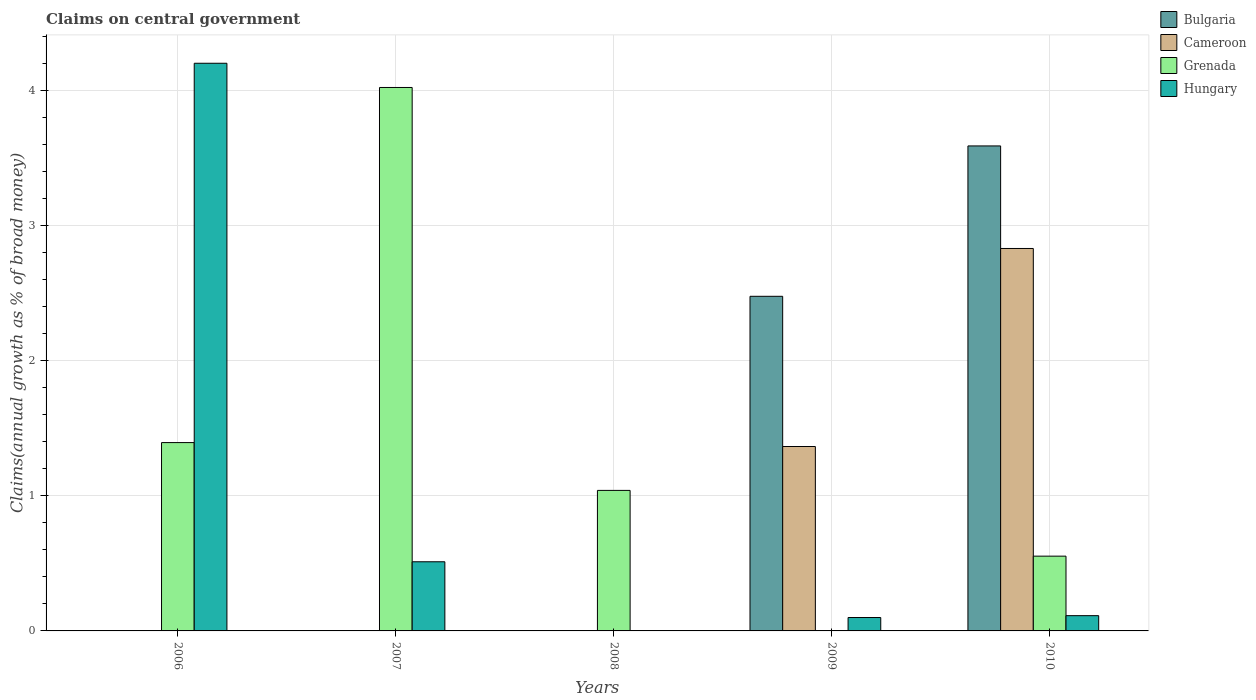Are the number of bars per tick equal to the number of legend labels?
Make the answer very short. No. What is the percentage of broad money claimed on centeral government in Hungary in 2007?
Make the answer very short. 0.51. Across all years, what is the maximum percentage of broad money claimed on centeral government in Bulgaria?
Offer a very short reply. 3.59. What is the total percentage of broad money claimed on centeral government in Bulgaria in the graph?
Give a very brief answer. 6.07. What is the difference between the percentage of broad money claimed on centeral government in Grenada in 2006 and that in 2010?
Your response must be concise. 0.84. What is the difference between the percentage of broad money claimed on centeral government in Cameroon in 2008 and the percentage of broad money claimed on centeral government in Bulgaria in 2009?
Give a very brief answer. -2.48. What is the average percentage of broad money claimed on centeral government in Bulgaria per year?
Keep it short and to the point. 1.21. In the year 2007, what is the difference between the percentage of broad money claimed on centeral government in Hungary and percentage of broad money claimed on centeral government in Grenada?
Ensure brevity in your answer.  -3.51. What is the ratio of the percentage of broad money claimed on centeral government in Grenada in 2006 to that in 2007?
Give a very brief answer. 0.35. What is the difference between the highest and the second highest percentage of broad money claimed on centeral government in Grenada?
Give a very brief answer. 2.63. What is the difference between the highest and the lowest percentage of broad money claimed on centeral government in Grenada?
Your answer should be compact. 4.03. What is the difference between two consecutive major ticks on the Y-axis?
Make the answer very short. 1. Does the graph contain any zero values?
Your response must be concise. Yes. How are the legend labels stacked?
Give a very brief answer. Vertical. What is the title of the graph?
Provide a short and direct response. Claims on central government. What is the label or title of the X-axis?
Keep it short and to the point. Years. What is the label or title of the Y-axis?
Provide a short and direct response. Claims(annual growth as % of broad money). What is the Claims(annual growth as % of broad money) in Bulgaria in 2006?
Your answer should be very brief. 0. What is the Claims(annual growth as % of broad money) of Cameroon in 2006?
Provide a short and direct response. 0. What is the Claims(annual growth as % of broad money) in Grenada in 2006?
Keep it short and to the point. 1.4. What is the Claims(annual growth as % of broad money) in Hungary in 2006?
Make the answer very short. 4.21. What is the Claims(annual growth as % of broad money) of Bulgaria in 2007?
Your answer should be compact. 0. What is the Claims(annual growth as % of broad money) of Grenada in 2007?
Your response must be concise. 4.03. What is the Claims(annual growth as % of broad money) in Hungary in 2007?
Ensure brevity in your answer.  0.51. What is the Claims(annual growth as % of broad money) of Bulgaria in 2008?
Offer a terse response. 0. What is the Claims(annual growth as % of broad money) in Cameroon in 2008?
Make the answer very short. 0. What is the Claims(annual growth as % of broad money) of Grenada in 2008?
Give a very brief answer. 1.04. What is the Claims(annual growth as % of broad money) in Bulgaria in 2009?
Keep it short and to the point. 2.48. What is the Claims(annual growth as % of broad money) of Cameroon in 2009?
Provide a succinct answer. 1.37. What is the Claims(annual growth as % of broad money) in Grenada in 2009?
Give a very brief answer. 0. What is the Claims(annual growth as % of broad money) of Hungary in 2009?
Give a very brief answer. 0.1. What is the Claims(annual growth as % of broad money) of Bulgaria in 2010?
Provide a short and direct response. 3.59. What is the Claims(annual growth as % of broad money) in Cameroon in 2010?
Offer a terse response. 2.83. What is the Claims(annual growth as % of broad money) in Grenada in 2010?
Your answer should be compact. 0.55. What is the Claims(annual growth as % of broad money) in Hungary in 2010?
Provide a short and direct response. 0.11. Across all years, what is the maximum Claims(annual growth as % of broad money) in Bulgaria?
Your answer should be very brief. 3.59. Across all years, what is the maximum Claims(annual growth as % of broad money) of Cameroon?
Give a very brief answer. 2.83. Across all years, what is the maximum Claims(annual growth as % of broad money) in Grenada?
Your response must be concise. 4.03. Across all years, what is the maximum Claims(annual growth as % of broad money) in Hungary?
Your answer should be very brief. 4.21. Across all years, what is the minimum Claims(annual growth as % of broad money) in Bulgaria?
Offer a terse response. 0. Across all years, what is the minimum Claims(annual growth as % of broad money) in Cameroon?
Give a very brief answer. 0. What is the total Claims(annual growth as % of broad money) in Bulgaria in the graph?
Provide a succinct answer. 6.07. What is the total Claims(annual growth as % of broad money) of Cameroon in the graph?
Offer a very short reply. 4.2. What is the total Claims(annual growth as % of broad money) of Grenada in the graph?
Ensure brevity in your answer.  7.02. What is the total Claims(annual growth as % of broad money) of Hungary in the graph?
Keep it short and to the point. 4.93. What is the difference between the Claims(annual growth as % of broad money) of Grenada in 2006 and that in 2007?
Your answer should be compact. -2.63. What is the difference between the Claims(annual growth as % of broad money) in Hungary in 2006 and that in 2007?
Your answer should be compact. 3.69. What is the difference between the Claims(annual growth as % of broad money) in Grenada in 2006 and that in 2008?
Offer a very short reply. 0.35. What is the difference between the Claims(annual growth as % of broad money) in Hungary in 2006 and that in 2009?
Your answer should be compact. 4.11. What is the difference between the Claims(annual growth as % of broad money) of Grenada in 2006 and that in 2010?
Offer a terse response. 0.84. What is the difference between the Claims(annual growth as % of broad money) of Hungary in 2006 and that in 2010?
Provide a short and direct response. 4.09. What is the difference between the Claims(annual growth as % of broad money) of Grenada in 2007 and that in 2008?
Your response must be concise. 2.98. What is the difference between the Claims(annual growth as % of broad money) of Hungary in 2007 and that in 2009?
Offer a very short reply. 0.41. What is the difference between the Claims(annual growth as % of broad money) of Grenada in 2007 and that in 2010?
Provide a succinct answer. 3.47. What is the difference between the Claims(annual growth as % of broad money) of Hungary in 2007 and that in 2010?
Give a very brief answer. 0.4. What is the difference between the Claims(annual growth as % of broad money) in Grenada in 2008 and that in 2010?
Your answer should be compact. 0.49. What is the difference between the Claims(annual growth as % of broad money) in Bulgaria in 2009 and that in 2010?
Give a very brief answer. -1.11. What is the difference between the Claims(annual growth as % of broad money) of Cameroon in 2009 and that in 2010?
Your response must be concise. -1.47. What is the difference between the Claims(annual growth as % of broad money) of Hungary in 2009 and that in 2010?
Your response must be concise. -0.01. What is the difference between the Claims(annual growth as % of broad money) of Grenada in 2006 and the Claims(annual growth as % of broad money) of Hungary in 2007?
Your answer should be compact. 0.88. What is the difference between the Claims(annual growth as % of broad money) of Grenada in 2006 and the Claims(annual growth as % of broad money) of Hungary in 2009?
Keep it short and to the point. 1.3. What is the difference between the Claims(annual growth as % of broad money) of Grenada in 2006 and the Claims(annual growth as % of broad money) of Hungary in 2010?
Your answer should be very brief. 1.28. What is the difference between the Claims(annual growth as % of broad money) of Grenada in 2007 and the Claims(annual growth as % of broad money) of Hungary in 2009?
Make the answer very short. 3.93. What is the difference between the Claims(annual growth as % of broad money) in Grenada in 2007 and the Claims(annual growth as % of broad money) in Hungary in 2010?
Ensure brevity in your answer.  3.91. What is the difference between the Claims(annual growth as % of broad money) of Grenada in 2008 and the Claims(annual growth as % of broad money) of Hungary in 2009?
Offer a terse response. 0.94. What is the difference between the Claims(annual growth as % of broad money) in Grenada in 2008 and the Claims(annual growth as % of broad money) in Hungary in 2010?
Provide a succinct answer. 0.93. What is the difference between the Claims(annual growth as % of broad money) of Bulgaria in 2009 and the Claims(annual growth as % of broad money) of Cameroon in 2010?
Your response must be concise. -0.35. What is the difference between the Claims(annual growth as % of broad money) in Bulgaria in 2009 and the Claims(annual growth as % of broad money) in Grenada in 2010?
Make the answer very short. 1.92. What is the difference between the Claims(annual growth as % of broad money) of Bulgaria in 2009 and the Claims(annual growth as % of broad money) of Hungary in 2010?
Make the answer very short. 2.37. What is the difference between the Claims(annual growth as % of broad money) of Cameroon in 2009 and the Claims(annual growth as % of broad money) of Grenada in 2010?
Keep it short and to the point. 0.81. What is the difference between the Claims(annual growth as % of broad money) of Cameroon in 2009 and the Claims(annual growth as % of broad money) of Hungary in 2010?
Ensure brevity in your answer.  1.25. What is the average Claims(annual growth as % of broad money) in Bulgaria per year?
Your answer should be very brief. 1.21. What is the average Claims(annual growth as % of broad money) in Cameroon per year?
Keep it short and to the point. 0.84. What is the average Claims(annual growth as % of broad money) in Grenada per year?
Make the answer very short. 1.4. In the year 2006, what is the difference between the Claims(annual growth as % of broad money) in Grenada and Claims(annual growth as % of broad money) in Hungary?
Your answer should be very brief. -2.81. In the year 2007, what is the difference between the Claims(annual growth as % of broad money) of Grenada and Claims(annual growth as % of broad money) of Hungary?
Offer a terse response. 3.51. In the year 2009, what is the difference between the Claims(annual growth as % of broad money) in Bulgaria and Claims(annual growth as % of broad money) in Cameroon?
Your answer should be very brief. 1.11. In the year 2009, what is the difference between the Claims(annual growth as % of broad money) in Bulgaria and Claims(annual growth as % of broad money) in Hungary?
Your response must be concise. 2.38. In the year 2009, what is the difference between the Claims(annual growth as % of broad money) of Cameroon and Claims(annual growth as % of broad money) of Hungary?
Your answer should be very brief. 1.27. In the year 2010, what is the difference between the Claims(annual growth as % of broad money) in Bulgaria and Claims(annual growth as % of broad money) in Cameroon?
Your response must be concise. 0.76. In the year 2010, what is the difference between the Claims(annual growth as % of broad money) in Bulgaria and Claims(annual growth as % of broad money) in Grenada?
Your response must be concise. 3.04. In the year 2010, what is the difference between the Claims(annual growth as % of broad money) of Bulgaria and Claims(annual growth as % of broad money) of Hungary?
Your response must be concise. 3.48. In the year 2010, what is the difference between the Claims(annual growth as % of broad money) in Cameroon and Claims(annual growth as % of broad money) in Grenada?
Make the answer very short. 2.28. In the year 2010, what is the difference between the Claims(annual growth as % of broad money) of Cameroon and Claims(annual growth as % of broad money) of Hungary?
Make the answer very short. 2.72. In the year 2010, what is the difference between the Claims(annual growth as % of broad money) of Grenada and Claims(annual growth as % of broad money) of Hungary?
Your answer should be very brief. 0.44. What is the ratio of the Claims(annual growth as % of broad money) in Grenada in 2006 to that in 2007?
Your answer should be compact. 0.35. What is the ratio of the Claims(annual growth as % of broad money) in Hungary in 2006 to that in 2007?
Offer a terse response. 8.21. What is the ratio of the Claims(annual growth as % of broad money) in Grenada in 2006 to that in 2008?
Your response must be concise. 1.34. What is the ratio of the Claims(annual growth as % of broad money) of Hungary in 2006 to that in 2009?
Provide a short and direct response. 42.38. What is the ratio of the Claims(annual growth as % of broad money) in Grenada in 2006 to that in 2010?
Your response must be concise. 2.52. What is the ratio of the Claims(annual growth as % of broad money) of Hungary in 2006 to that in 2010?
Provide a succinct answer. 37.19. What is the ratio of the Claims(annual growth as % of broad money) of Grenada in 2007 to that in 2008?
Your response must be concise. 3.87. What is the ratio of the Claims(annual growth as % of broad money) in Hungary in 2007 to that in 2009?
Your answer should be compact. 5.16. What is the ratio of the Claims(annual growth as % of broad money) of Grenada in 2007 to that in 2010?
Provide a short and direct response. 7.27. What is the ratio of the Claims(annual growth as % of broad money) of Hungary in 2007 to that in 2010?
Your answer should be very brief. 4.53. What is the ratio of the Claims(annual growth as % of broad money) of Grenada in 2008 to that in 2010?
Your response must be concise. 1.88. What is the ratio of the Claims(annual growth as % of broad money) in Bulgaria in 2009 to that in 2010?
Provide a succinct answer. 0.69. What is the ratio of the Claims(annual growth as % of broad money) in Cameroon in 2009 to that in 2010?
Offer a terse response. 0.48. What is the ratio of the Claims(annual growth as % of broad money) in Hungary in 2009 to that in 2010?
Provide a short and direct response. 0.88. What is the difference between the highest and the second highest Claims(annual growth as % of broad money) of Grenada?
Provide a succinct answer. 2.63. What is the difference between the highest and the second highest Claims(annual growth as % of broad money) of Hungary?
Provide a succinct answer. 3.69. What is the difference between the highest and the lowest Claims(annual growth as % of broad money) in Bulgaria?
Your answer should be very brief. 3.59. What is the difference between the highest and the lowest Claims(annual growth as % of broad money) in Cameroon?
Ensure brevity in your answer.  2.83. What is the difference between the highest and the lowest Claims(annual growth as % of broad money) in Grenada?
Keep it short and to the point. 4.03. What is the difference between the highest and the lowest Claims(annual growth as % of broad money) in Hungary?
Your answer should be very brief. 4.21. 